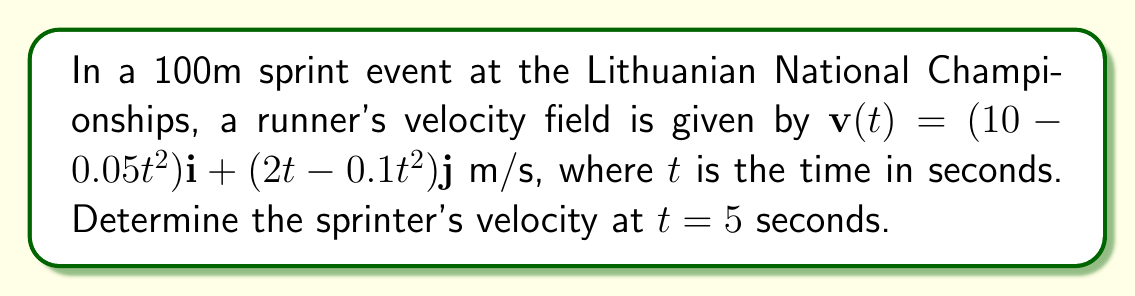Help me with this question. To find the sprinter's velocity at $t = 5$ seconds, we need to evaluate the given velocity field at that time:

1) The velocity field is given as:
   $$\mathbf{v}(t) = (10 - 0.05t^2)\mathbf{i} + (2t - 0.1t^2)\mathbf{j}$$

2) We need to substitute $t = 5$ into this equation:
   $$\mathbf{v}(5) = (10 - 0.05(5)^2)\mathbf{i} + (2(5) - 0.1(5)^2)\mathbf{j}$$

3) Let's evaluate the $\mathbf{i}$ component:
   $10 - 0.05(5)^2 = 10 - 0.05(25) = 10 - 1.25 = 8.75$

4) Now, let's evaluate the $\mathbf{j}$ component:
   $2(5) - 0.1(5)^2 = 10 - 0.1(25) = 10 - 2.5 = 7.5$

5) Therefore, the velocity vector at $t = 5$ seconds is:
   $$\mathbf{v}(5) = 8.75\mathbf{i} + 7.5\mathbf{j}$$

6) To find the magnitude of this velocity (speed), we use the Pythagorean theorem:
   $$|\mathbf{v}(5)| = \sqrt{8.75^2 + 7.5^2} = \sqrt{76.5625 + 56.25} = \sqrt{132.8125} \approx 11.52$$

Thus, the sprinter's velocity at $t = 5$ seconds is $8.75\mathbf{i} + 7.5\mathbf{j}$ m/s, with a speed of approximately 11.52 m/s.
Answer: $8.75\mathbf{i} + 7.5\mathbf{j}$ m/s 